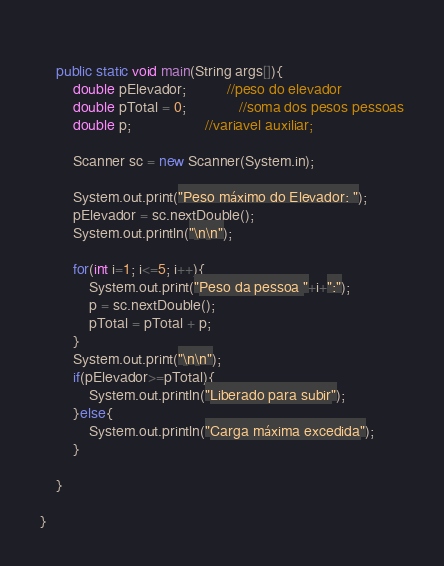Convert code to text. <code><loc_0><loc_0><loc_500><loc_500><_Java_>    
    public static void main(String args[]){
        double pElevador;          //peso do elevador
        double pTotal = 0;             //soma dos pesos pessoas
        double p;                  //variavel auxiliar;
        
        Scanner sc = new Scanner(System.in);
        
        System.out.print("Peso máximo do Elevador: ");
        pElevador = sc.nextDouble();
        System.out.println("\n\n");
        
        for(int i=1; i<=5; i++){
            System.out.print("Peso da pessoa "+i+":");
            p = sc.nextDouble();
            pTotal = pTotal + p;
        }
        System.out.print("\n\n");
        if(pElevador>=pTotal){
            System.out.println("Liberado para subir");
        }else{
            System.out.println("Carga máxima excedida");
        }
        
    }
    
}
</code> 